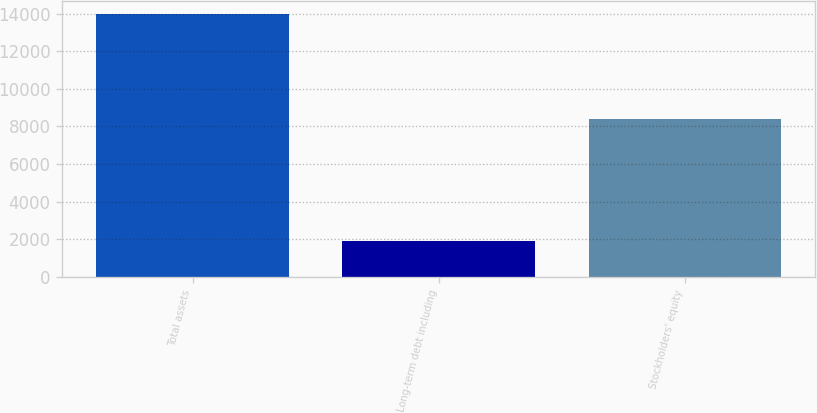Convert chart. <chart><loc_0><loc_0><loc_500><loc_500><bar_chart><fcel>Total assets<fcel>Long-term debt including<fcel>Stockholders' equity<nl><fcel>13992<fcel>1918<fcel>8376<nl></chart> 